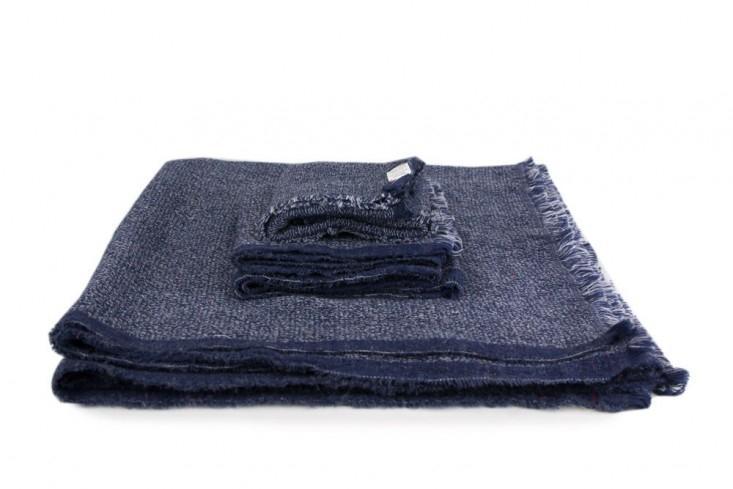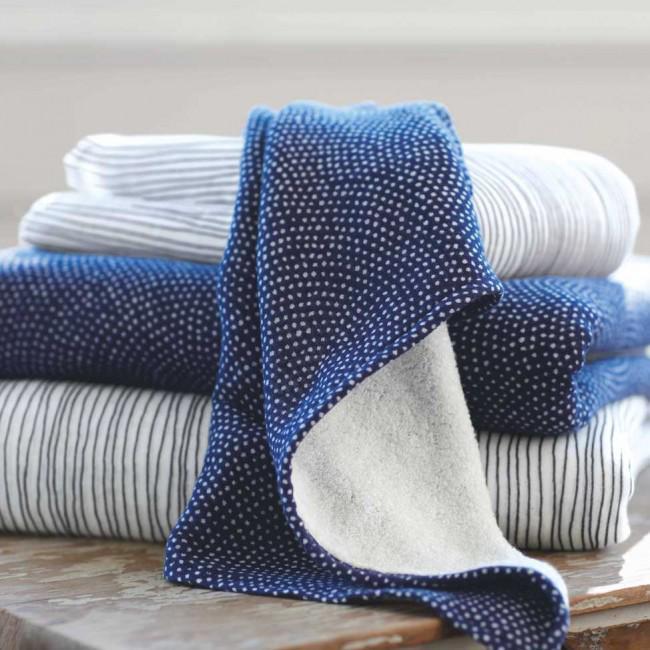The first image is the image on the left, the second image is the image on the right. Examine the images to the left and right. Is the description "One of the images shows a folded gray item with a distinctive weave." accurate? Answer yes or no. No. 